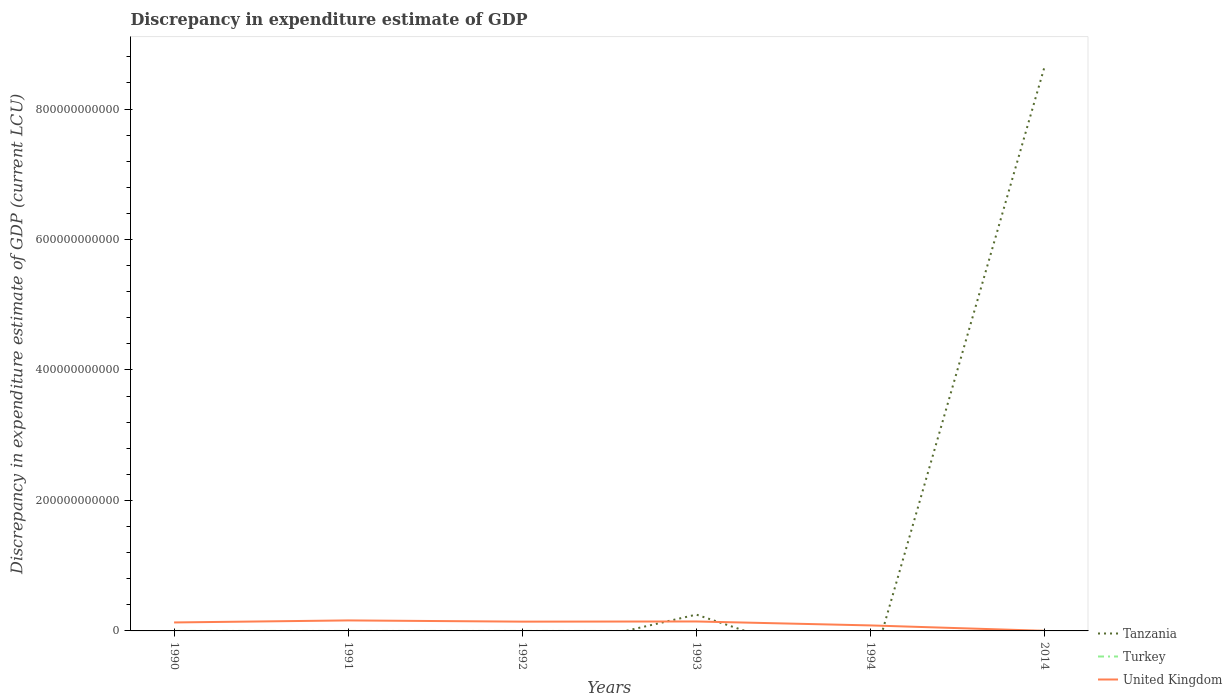How many different coloured lines are there?
Make the answer very short. 3. Does the line corresponding to Tanzania intersect with the line corresponding to Turkey?
Provide a short and direct response. Yes. What is the total discrepancy in expenditure estimate of GDP in Tanzania in the graph?
Keep it short and to the point. -8.40e+11. What is the difference between the highest and the second highest discrepancy in expenditure estimate of GDP in Turkey?
Ensure brevity in your answer.  4.80e+05. Is the discrepancy in expenditure estimate of GDP in United Kingdom strictly greater than the discrepancy in expenditure estimate of GDP in Tanzania over the years?
Your answer should be compact. No. How many years are there in the graph?
Ensure brevity in your answer.  6. What is the difference between two consecutive major ticks on the Y-axis?
Provide a short and direct response. 2.00e+11. Does the graph contain any zero values?
Your answer should be very brief. Yes. Where does the legend appear in the graph?
Your response must be concise. Bottom right. How are the legend labels stacked?
Make the answer very short. Vertical. What is the title of the graph?
Provide a succinct answer. Discrepancy in expenditure estimate of GDP. What is the label or title of the Y-axis?
Give a very brief answer. Discrepancy in expenditure estimate of GDP (current LCU). What is the Discrepancy in expenditure estimate of GDP (current LCU) of Turkey in 1990?
Your answer should be very brief. 4.80e+05. What is the Discrepancy in expenditure estimate of GDP (current LCU) of United Kingdom in 1990?
Make the answer very short. 1.30e+1. What is the Discrepancy in expenditure estimate of GDP (current LCU) in Turkey in 1991?
Offer a very short reply. 0. What is the Discrepancy in expenditure estimate of GDP (current LCU) in United Kingdom in 1991?
Offer a terse response. 1.61e+1. What is the Discrepancy in expenditure estimate of GDP (current LCU) of Tanzania in 1992?
Offer a very short reply. 0. What is the Discrepancy in expenditure estimate of GDP (current LCU) in United Kingdom in 1992?
Provide a short and direct response. 1.42e+1. What is the Discrepancy in expenditure estimate of GDP (current LCU) in Tanzania in 1993?
Your response must be concise. 2.50e+1. What is the Discrepancy in expenditure estimate of GDP (current LCU) in United Kingdom in 1993?
Your answer should be compact. 1.45e+1. What is the Discrepancy in expenditure estimate of GDP (current LCU) of United Kingdom in 1994?
Your answer should be very brief. 8.44e+09. What is the Discrepancy in expenditure estimate of GDP (current LCU) in Tanzania in 2014?
Ensure brevity in your answer.  8.65e+11. What is the Discrepancy in expenditure estimate of GDP (current LCU) in Turkey in 2014?
Offer a very short reply. 0. What is the Discrepancy in expenditure estimate of GDP (current LCU) in United Kingdom in 2014?
Make the answer very short. 1.65e+08. Across all years, what is the maximum Discrepancy in expenditure estimate of GDP (current LCU) in Tanzania?
Keep it short and to the point. 8.65e+11. Across all years, what is the maximum Discrepancy in expenditure estimate of GDP (current LCU) of Turkey?
Your response must be concise. 4.80e+05. Across all years, what is the maximum Discrepancy in expenditure estimate of GDP (current LCU) in United Kingdom?
Give a very brief answer. 1.61e+1. Across all years, what is the minimum Discrepancy in expenditure estimate of GDP (current LCU) in Turkey?
Your response must be concise. 0. Across all years, what is the minimum Discrepancy in expenditure estimate of GDP (current LCU) of United Kingdom?
Ensure brevity in your answer.  1.65e+08. What is the total Discrepancy in expenditure estimate of GDP (current LCU) of Tanzania in the graph?
Your answer should be very brief. 8.90e+11. What is the total Discrepancy in expenditure estimate of GDP (current LCU) of Turkey in the graph?
Your answer should be very brief. 4.80e+05. What is the total Discrepancy in expenditure estimate of GDP (current LCU) of United Kingdom in the graph?
Provide a succinct answer. 6.64e+1. What is the difference between the Discrepancy in expenditure estimate of GDP (current LCU) in United Kingdom in 1990 and that in 1991?
Make the answer very short. -3.10e+09. What is the difference between the Discrepancy in expenditure estimate of GDP (current LCU) in United Kingdom in 1990 and that in 1992?
Keep it short and to the point. -1.23e+09. What is the difference between the Discrepancy in expenditure estimate of GDP (current LCU) in United Kingdom in 1990 and that in 1993?
Your response must be concise. -1.51e+09. What is the difference between the Discrepancy in expenditure estimate of GDP (current LCU) in United Kingdom in 1990 and that in 1994?
Offer a terse response. 4.55e+09. What is the difference between the Discrepancy in expenditure estimate of GDP (current LCU) in United Kingdom in 1990 and that in 2014?
Provide a succinct answer. 1.28e+1. What is the difference between the Discrepancy in expenditure estimate of GDP (current LCU) of United Kingdom in 1991 and that in 1992?
Your answer should be very brief. 1.87e+09. What is the difference between the Discrepancy in expenditure estimate of GDP (current LCU) of United Kingdom in 1991 and that in 1993?
Ensure brevity in your answer.  1.59e+09. What is the difference between the Discrepancy in expenditure estimate of GDP (current LCU) of United Kingdom in 1991 and that in 1994?
Provide a succinct answer. 7.65e+09. What is the difference between the Discrepancy in expenditure estimate of GDP (current LCU) in United Kingdom in 1991 and that in 2014?
Keep it short and to the point. 1.59e+1. What is the difference between the Discrepancy in expenditure estimate of GDP (current LCU) in United Kingdom in 1992 and that in 1993?
Ensure brevity in your answer.  -2.77e+08. What is the difference between the Discrepancy in expenditure estimate of GDP (current LCU) of United Kingdom in 1992 and that in 1994?
Keep it short and to the point. 5.78e+09. What is the difference between the Discrepancy in expenditure estimate of GDP (current LCU) in United Kingdom in 1992 and that in 2014?
Give a very brief answer. 1.41e+1. What is the difference between the Discrepancy in expenditure estimate of GDP (current LCU) in United Kingdom in 1993 and that in 1994?
Offer a very short reply. 6.06e+09. What is the difference between the Discrepancy in expenditure estimate of GDP (current LCU) in Tanzania in 1993 and that in 2014?
Make the answer very short. -8.40e+11. What is the difference between the Discrepancy in expenditure estimate of GDP (current LCU) of United Kingdom in 1993 and that in 2014?
Offer a very short reply. 1.43e+1. What is the difference between the Discrepancy in expenditure estimate of GDP (current LCU) of United Kingdom in 1994 and that in 2014?
Make the answer very short. 8.28e+09. What is the difference between the Discrepancy in expenditure estimate of GDP (current LCU) in Turkey in 1990 and the Discrepancy in expenditure estimate of GDP (current LCU) in United Kingdom in 1991?
Give a very brief answer. -1.61e+1. What is the difference between the Discrepancy in expenditure estimate of GDP (current LCU) in Turkey in 1990 and the Discrepancy in expenditure estimate of GDP (current LCU) in United Kingdom in 1992?
Keep it short and to the point. -1.42e+1. What is the difference between the Discrepancy in expenditure estimate of GDP (current LCU) of Turkey in 1990 and the Discrepancy in expenditure estimate of GDP (current LCU) of United Kingdom in 1993?
Make the answer very short. -1.45e+1. What is the difference between the Discrepancy in expenditure estimate of GDP (current LCU) of Turkey in 1990 and the Discrepancy in expenditure estimate of GDP (current LCU) of United Kingdom in 1994?
Keep it short and to the point. -8.44e+09. What is the difference between the Discrepancy in expenditure estimate of GDP (current LCU) of Turkey in 1990 and the Discrepancy in expenditure estimate of GDP (current LCU) of United Kingdom in 2014?
Your response must be concise. -1.65e+08. What is the difference between the Discrepancy in expenditure estimate of GDP (current LCU) of Tanzania in 1993 and the Discrepancy in expenditure estimate of GDP (current LCU) of United Kingdom in 1994?
Make the answer very short. 1.66e+1. What is the difference between the Discrepancy in expenditure estimate of GDP (current LCU) of Tanzania in 1993 and the Discrepancy in expenditure estimate of GDP (current LCU) of United Kingdom in 2014?
Provide a short and direct response. 2.48e+1. What is the average Discrepancy in expenditure estimate of GDP (current LCU) in Tanzania per year?
Provide a short and direct response. 1.48e+11. What is the average Discrepancy in expenditure estimate of GDP (current LCU) in Turkey per year?
Offer a very short reply. 8.00e+04. What is the average Discrepancy in expenditure estimate of GDP (current LCU) of United Kingdom per year?
Your answer should be very brief. 1.11e+1. In the year 1990, what is the difference between the Discrepancy in expenditure estimate of GDP (current LCU) of Turkey and Discrepancy in expenditure estimate of GDP (current LCU) of United Kingdom?
Keep it short and to the point. -1.30e+1. In the year 1993, what is the difference between the Discrepancy in expenditure estimate of GDP (current LCU) in Tanzania and Discrepancy in expenditure estimate of GDP (current LCU) in United Kingdom?
Your answer should be compact. 1.05e+1. In the year 2014, what is the difference between the Discrepancy in expenditure estimate of GDP (current LCU) in Tanzania and Discrepancy in expenditure estimate of GDP (current LCU) in United Kingdom?
Provide a succinct answer. 8.64e+11. What is the ratio of the Discrepancy in expenditure estimate of GDP (current LCU) of United Kingdom in 1990 to that in 1991?
Provide a short and direct response. 0.81. What is the ratio of the Discrepancy in expenditure estimate of GDP (current LCU) of United Kingdom in 1990 to that in 1992?
Your answer should be very brief. 0.91. What is the ratio of the Discrepancy in expenditure estimate of GDP (current LCU) in United Kingdom in 1990 to that in 1993?
Offer a terse response. 0.9. What is the ratio of the Discrepancy in expenditure estimate of GDP (current LCU) of United Kingdom in 1990 to that in 1994?
Provide a short and direct response. 1.54. What is the ratio of the Discrepancy in expenditure estimate of GDP (current LCU) of United Kingdom in 1990 to that in 2014?
Your response must be concise. 78.72. What is the ratio of the Discrepancy in expenditure estimate of GDP (current LCU) of United Kingdom in 1991 to that in 1992?
Provide a succinct answer. 1.13. What is the ratio of the Discrepancy in expenditure estimate of GDP (current LCU) of United Kingdom in 1991 to that in 1993?
Provide a short and direct response. 1.11. What is the ratio of the Discrepancy in expenditure estimate of GDP (current LCU) of United Kingdom in 1991 to that in 1994?
Offer a very short reply. 1.91. What is the ratio of the Discrepancy in expenditure estimate of GDP (current LCU) of United Kingdom in 1991 to that in 2014?
Your response must be concise. 97.5. What is the ratio of the Discrepancy in expenditure estimate of GDP (current LCU) of United Kingdom in 1992 to that in 1993?
Offer a very short reply. 0.98. What is the ratio of the Discrepancy in expenditure estimate of GDP (current LCU) of United Kingdom in 1992 to that in 1994?
Ensure brevity in your answer.  1.68. What is the ratio of the Discrepancy in expenditure estimate of GDP (current LCU) of United Kingdom in 1992 to that in 2014?
Keep it short and to the point. 86.19. What is the ratio of the Discrepancy in expenditure estimate of GDP (current LCU) of United Kingdom in 1993 to that in 1994?
Make the answer very short. 1.72. What is the ratio of the Discrepancy in expenditure estimate of GDP (current LCU) in Tanzania in 1993 to that in 2014?
Offer a terse response. 0.03. What is the ratio of the Discrepancy in expenditure estimate of GDP (current LCU) in United Kingdom in 1993 to that in 2014?
Your answer should be compact. 87.87. What is the ratio of the Discrepancy in expenditure estimate of GDP (current LCU) of United Kingdom in 1994 to that in 2014?
Give a very brief answer. 51.16. What is the difference between the highest and the second highest Discrepancy in expenditure estimate of GDP (current LCU) of United Kingdom?
Give a very brief answer. 1.59e+09. What is the difference between the highest and the lowest Discrepancy in expenditure estimate of GDP (current LCU) in Tanzania?
Offer a very short reply. 8.65e+11. What is the difference between the highest and the lowest Discrepancy in expenditure estimate of GDP (current LCU) of Turkey?
Keep it short and to the point. 4.80e+05. What is the difference between the highest and the lowest Discrepancy in expenditure estimate of GDP (current LCU) in United Kingdom?
Make the answer very short. 1.59e+1. 